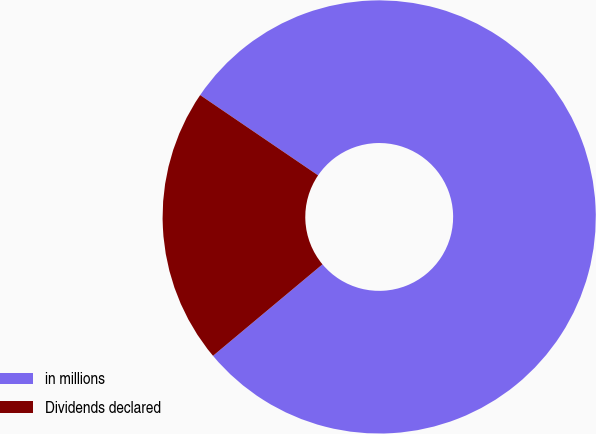Convert chart to OTSL. <chart><loc_0><loc_0><loc_500><loc_500><pie_chart><fcel>in millions<fcel>Dividends declared<nl><fcel>79.41%<fcel>20.59%<nl></chart> 